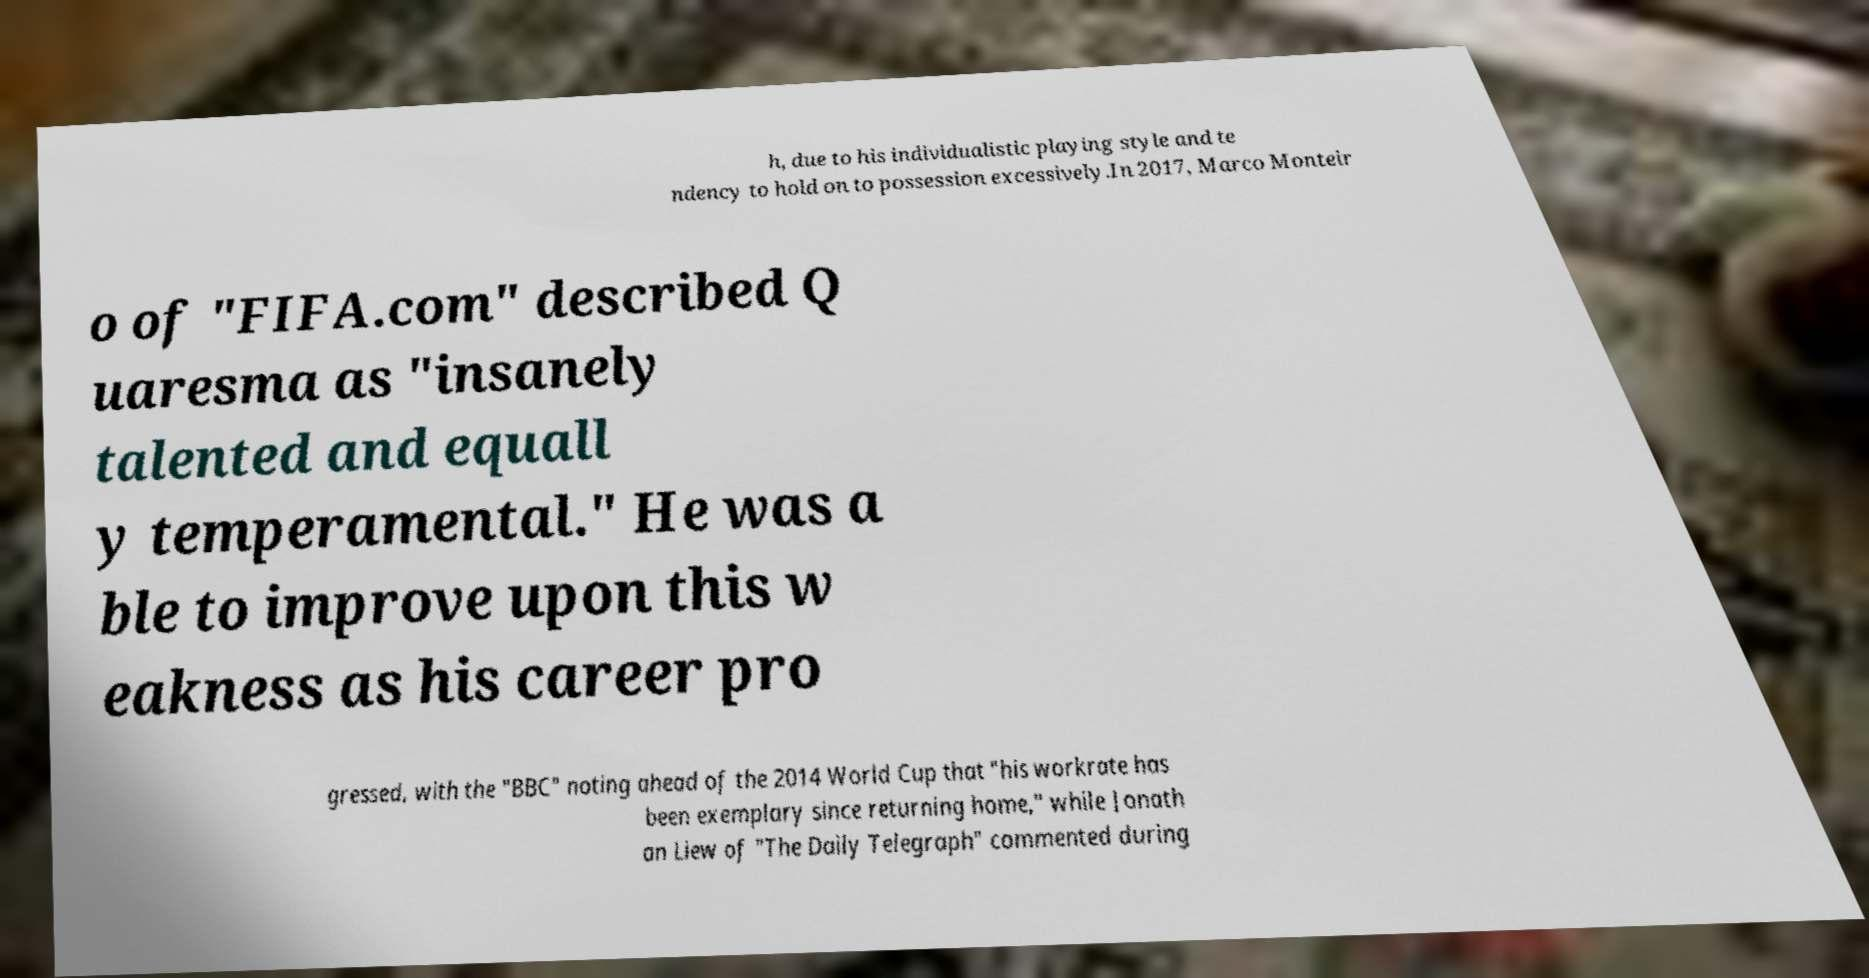There's text embedded in this image that I need extracted. Can you transcribe it verbatim? h, due to his individualistic playing style and te ndency to hold on to possession excessively.In 2017, Marco Monteir o of "FIFA.com" described Q uaresma as "insanely talented and equall y temperamental." He was a ble to improve upon this w eakness as his career pro gressed, with the "BBC" noting ahead of the 2014 World Cup that "his workrate has been exemplary since returning home," while Jonath an Liew of "The Daily Telegraph" commented during 